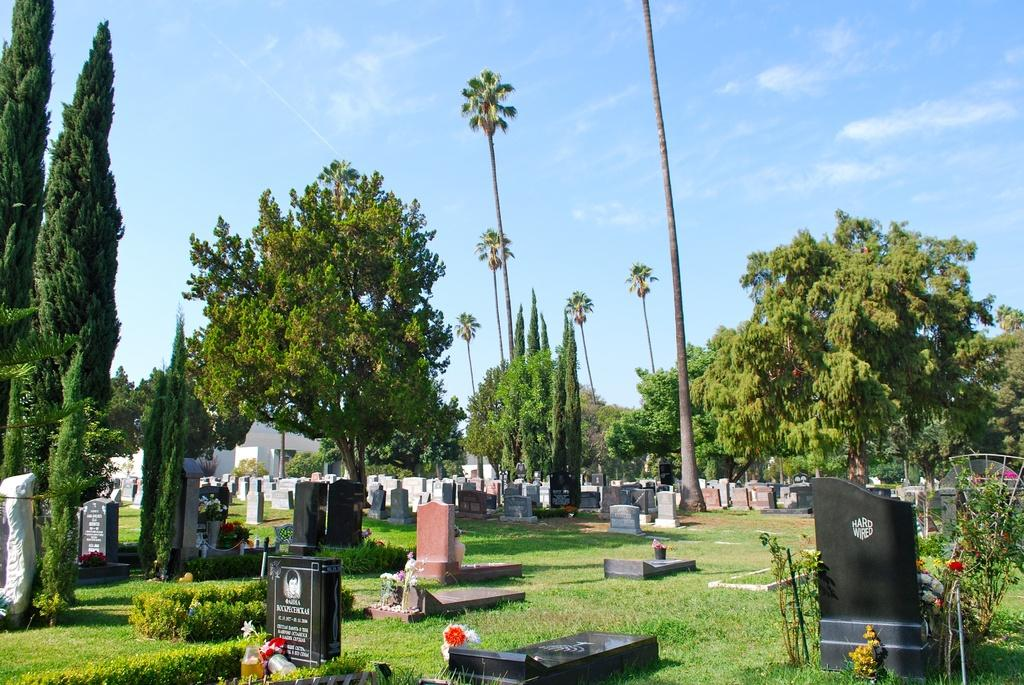What is the main subject in the foreground of the image? There is a graveyard in the foreground of the image. What can be seen in the middle of the image? There are tall trees in the middle of the image. What is visible at the top of the image? The sky is visible at the top of the image. What time of day is it in the image, as indicated by the sea? There is no sea present in the image, so it is not possible to determine the time of day based on that information. 